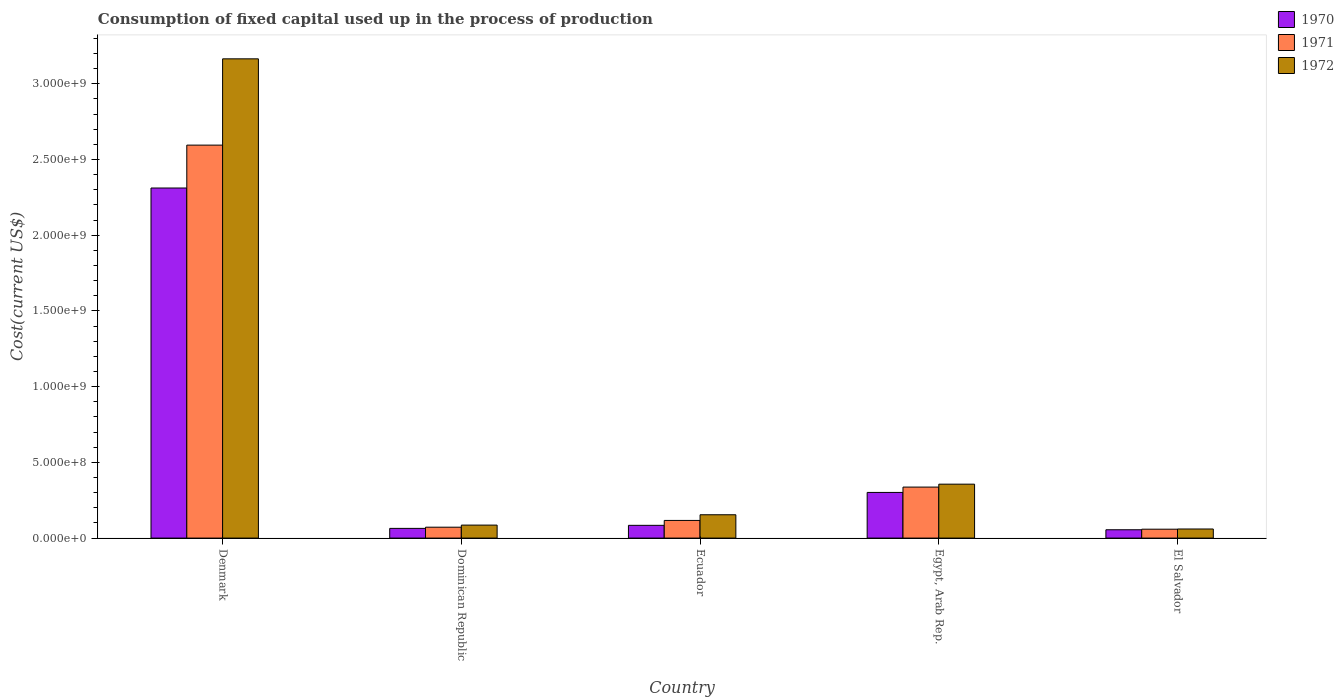How many groups of bars are there?
Offer a terse response. 5. How many bars are there on the 2nd tick from the right?
Offer a very short reply. 3. What is the label of the 3rd group of bars from the left?
Give a very brief answer. Ecuador. In how many cases, is the number of bars for a given country not equal to the number of legend labels?
Provide a succinct answer. 0. What is the amount consumed in the process of production in 1970 in El Salvador?
Offer a very short reply. 5.51e+07. Across all countries, what is the maximum amount consumed in the process of production in 1971?
Make the answer very short. 2.60e+09. Across all countries, what is the minimum amount consumed in the process of production in 1971?
Your response must be concise. 5.88e+07. In which country was the amount consumed in the process of production in 1971 maximum?
Provide a succinct answer. Denmark. In which country was the amount consumed in the process of production in 1972 minimum?
Keep it short and to the point. El Salvador. What is the total amount consumed in the process of production in 1972 in the graph?
Make the answer very short. 3.82e+09. What is the difference between the amount consumed in the process of production in 1971 in Dominican Republic and that in Ecuador?
Ensure brevity in your answer.  -4.47e+07. What is the difference between the amount consumed in the process of production in 1970 in Ecuador and the amount consumed in the process of production in 1971 in Denmark?
Keep it short and to the point. -2.51e+09. What is the average amount consumed in the process of production in 1970 per country?
Ensure brevity in your answer.  5.63e+08. What is the difference between the amount consumed in the process of production of/in 1970 and amount consumed in the process of production of/in 1972 in Dominican Republic?
Your answer should be compact. -2.17e+07. In how many countries, is the amount consumed in the process of production in 1970 greater than 2300000000 US$?
Your answer should be compact. 1. What is the ratio of the amount consumed in the process of production in 1970 in Dominican Republic to that in Egypt, Arab Rep.?
Your answer should be very brief. 0.21. Is the difference between the amount consumed in the process of production in 1970 in Ecuador and El Salvador greater than the difference between the amount consumed in the process of production in 1972 in Ecuador and El Salvador?
Provide a short and direct response. No. What is the difference between the highest and the second highest amount consumed in the process of production in 1972?
Give a very brief answer. -2.02e+08. What is the difference between the highest and the lowest amount consumed in the process of production in 1971?
Keep it short and to the point. 2.54e+09. In how many countries, is the amount consumed in the process of production in 1971 greater than the average amount consumed in the process of production in 1971 taken over all countries?
Offer a very short reply. 1. What does the 2nd bar from the left in Ecuador represents?
Provide a short and direct response. 1971. What does the 1st bar from the right in El Salvador represents?
Provide a succinct answer. 1972. Is it the case that in every country, the sum of the amount consumed in the process of production in 1972 and amount consumed in the process of production in 1971 is greater than the amount consumed in the process of production in 1970?
Ensure brevity in your answer.  Yes. How many countries are there in the graph?
Your response must be concise. 5. What is the difference between two consecutive major ticks on the Y-axis?
Provide a short and direct response. 5.00e+08. Are the values on the major ticks of Y-axis written in scientific E-notation?
Keep it short and to the point. Yes. Does the graph contain any zero values?
Your answer should be compact. No. Where does the legend appear in the graph?
Give a very brief answer. Top right. How many legend labels are there?
Your answer should be very brief. 3. What is the title of the graph?
Your answer should be compact. Consumption of fixed capital used up in the process of production. What is the label or title of the Y-axis?
Offer a very short reply. Cost(current US$). What is the Cost(current US$) in 1970 in Denmark?
Keep it short and to the point. 2.31e+09. What is the Cost(current US$) of 1971 in Denmark?
Provide a succinct answer. 2.60e+09. What is the Cost(current US$) in 1972 in Denmark?
Make the answer very short. 3.17e+09. What is the Cost(current US$) of 1970 in Dominican Republic?
Keep it short and to the point. 6.41e+07. What is the Cost(current US$) of 1971 in Dominican Republic?
Your answer should be compact. 7.20e+07. What is the Cost(current US$) in 1972 in Dominican Republic?
Provide a succinct answer. 8.58e+07. What is the Cost(current US$) in 1970 in Ecuador?
Your answer should be very brief. 8.43e+07. What is the Cost(current US$) of 1971 in Ecuador?
Your answer should be very brief. 1.17e+08. What is the Cost(current US$) of 1972 in Ecuador?
Your response must be concise. 1.54e+08. What is the Cost(current US$) in 1970 in Egypt, Arab Rep.?
Offer a very short reply. 3.02e+08. What is the Cost(current US$) in 1971 in Egypt, Arab Rep.?
Your response must be concise. 3.37e+08. What is the Cost(current US$) in 1972 in Egypt, Arab Rep.?
Give a very brief answer. 3.56e+08. What is the Cost(current US$) in 1970 in El Salvador?
Keep it short and to the point. 5.51e+07. What is the Cost(current US$) of 1971 in El Salvador?
Give a very brief answer. 5.88e+07. What is the Cost(current US$) in 1972 in El Salvador?
Provide a short and direct response. 6.01e+07. Across all countries, what is the maximum Cost(current US$) of 1970?
Offer a terse response. 2.31e+09. Across all countries, what is the maximum Cost(current US$) of 1971?
Provide a short and direct response. 2.60e+09. Across all countries, what is the maximum Cost(current US$) in 1972?
Provide a succinct answer. 3.17e+09. Across all countries, what is the minimum Cost(current US$) of 1970?
Offer a very short reply. 5.51e+07. Across all countries, what is the minimum Cost(current US$) of 1971?
Provide a short and direct response. 5.88e+07. Across all countries, what is the minimum Cost(current US$) of 1972?
Give a very brief answer. 6.01e+07. What is the total Cost(current US$) of 1970 in the graph?
Ensure brevity in your answer.  2.82e+09. What is the total Cost(current US$) of 1971 in the graph?
Your response must be concise. 3.18e+09. What is the total Cost(current US$) of 1972 in the graph?
Your answer should be very brief. 3.82e+09. What is the difference between the Cost(current US$) in 1970 in Denmark and that in Dominican Republic?
Your answer should be compact. 2.25e+09. What is the difference between the Cost(current US$) in 1971 in Denmark and that in Dominican Republic?
Offer a very short reply. 2.52e+09. What is the difference between the Cost(current US$) of 1972 in Denmark and that in Dominican Republic?
Your answer should be compact. 3.08e+09. What is the difference between the Cost(current US$) in 1970 in Denmark and that in Ecuador?
Offer a terse response. 2.23e+09. What is the difference between the Cost(current US$) in 1971 in Denmark and that in Ecuador?
Keep it short and to the point. 2.48e+09. What is the difference between the Cost(current US$) of 1972 in Denmark and that in Ecuador?
Give a very brief answer. 3.01e+09. What is the difference between the Cost(current US$) in 1970 in Denmark and that in Egypt, Arab Rep.?
Your response must be concise. 2.01e+09. What is the difference between the Cost(current US$) in 1971 in Denmark and that in Egypt, Arab Rep.?
Your answer should be very brief. 2.26e+09. What is the difference between the Cost(current US$) of 1972 in Denmark and that in Egypt, Arab Rep.?
Offer a terse response. 2.81e+09. What is the difference between the Cost(current US$) in 1970 in Denmark and that in El Salvador?
Give a very brief answer. 2.26e+09. What is the difference between the Cost(current US$) of 1971 in Denmark and that in El Salvador?
Give a very brief answer. 2.54e+09. What is the difference between the Cost(current US$) in 1972 in Denmark and that in El Salvador?
Provide a short and direct response. 3.11e+09. What is the difference between the Cost(current US$) in 1970 in Dominican Republic and that in Ecuador?
Provide a succinct answer. -2.01e+07. What is the difference between the Cost(current US$) of 1971 in Dominican Republic and that in Ecuador?
Your response must be concise. -4.47e+07. What is the difference between the Cost(current US$) of 1972 in Dominican Republic and that in Ecuador?
Make the answer very short. -6.83e+07. What is the difference between the Cost(current US$) in 1970 in Dominican Republic and that in Egypt, Arab Rep.?
Keep it short and to the point. -2.37e+08. What is the difference between the Cost(current US$) of 1971 in Dominican Republic and that in Egypt, Arab Rep.?
Keep it short and to the point. -2.65e+08. What is the difference between the Cost(current US$) in 1972 in Dominican Republic and that in Egypt, Arab Rep.?
Your answer should be compact. -2.70e+08. What is the difference between the Cost(current US$) of 1970 in Dominican Republic and that in El Salvador?
Make the answer very short. 9.05e+06. What is the difference between the Cost(current US$) in 1971 in Dominican Republic and that in El Salvador?
Make the answer very short. 1.32e+07. What is the difference between the Cost(current US$) of 1972 in Dominican Republic and that in El Salvador?
Give a very brief answer. 2.57e+07. What is the difference between the Cost(current US$) in 1970 in Ecuador and that in Egypt, Arab Rep.?
Your response must be concise. -2.17e+08. What is the difference between the Cost(current US$) of 1971 in Ecuador and that in Egypt, Arab Rep.?
Your response must be concise. -2.20e+08. What is the difference between the Cost(current US$) in 1972 in Ecuador and that in Egypt, Arab Rep.?
Keep it short and to the point. -2.02e+08. What is the difference between the Cost(current US$) in 1970 in Ecuador and that in El Salvador?
Offer a very short reply. 2.92e+07. What is the difference between the Cost(current US$) in 1971 in Ecuador and that in El Salvador?
Offer a very short reply. 5.79e+07. What is the difference between the Cost(current US$) in 1972 in Ecuador and that in El Salvador?
Your response must be concise. 9.40e+07. What is the difference between the Cost(current US$) in 1970 in Egypt, Arab Rep. and that in El Salvador?
Your answer should be compact. 2.47e+08. What is the difference between the Cost(current US$) in 1971 in Egypt, Arab Rep. and that in El Salvador?
Your answer should be very brief. 2.78e+08. What is the difference between the Cost(current US$) of 1972 in Egypt, Arab Rep. and that in El Salvador?
Your answer should be compact. 2.96e+08. What is the difference between the Cost(current US$) in 1970 in Denmark and the Cost(current US$) in 1971 in Dominican Republic?
Offer a terse response. 2.24e+09. What is the difference between the Cost(current US$) in 1970 in Denmark and the Cost(current US$) in 1972 in Dominican Republic?
Provide a short and direct response. 2.23e+09. What is the difference between the Cost(current US$) of 1971 in Denmark and the Cost(current US$) of 1972 in Dominican Republic?
Provide a short and direct response. 2.51e+09. What is the difference between the Cost(current US$) in 1970 in Denmark and the Cost(current US$) in 1971 in Ecuador?
Make the answer very short. 2.20e+09. What is the difference between the Cost(current US$) of 1970 in Denmark and the Cost(current US$) of 1972 in Ecuador?
Ensure brevity in your answer.  2.16e+09. What is the difference between the Cost(current US$) in 1971 in Denmark and the Cost(current US$) in 1972 in Ecuador?
Offer a very short reply. 2.44e+09. What is the difference between the Cost(current US$) in 1970 in Denmark and the Cost(current US$) in 1971 in Egypt, Arab Rep.?
Keep it short and to the point. 1.98e+09. What is the difference between the Cost(current US$) in 1970 in Denmark and the Cost(current US$) in 1972 in Egypt, Arab Rep.?
Keep it short and to the point. 1.96e+09. What is the difference between the Cost(current US$) of 1971 in Denmark and the Cost(current US$) of 1972 in Egypt, Arab Rep.?
Give a very brief answer. 2.24e+09. What is the difference between the Cost(current US$) of 1970 in Denmark and the Cost(current US$) of 1971 in El Salvador?
Offer a terse response. 2.25e+09. What is the difference between the Cost(current US$) in 1970 in Denmark and the Cost(current US$) in 1972 in El Salvador?
Offer a very short reply. 2.25e+09. What is the difference between the Cost(current US$) of 1971 in Denmark and the Cost(current US$) of 1972 in El Salvador?
Provide a succinct answer. 2.54e+09. What is the difference between the Cost(current US$) of 1970 in Dominican Republic and the Cost(current US$) of 1971 in Ecuador?
Give a very brief answer. -5.25e+07. What is the difference between the Cost(current US$) of 1970 in Dominican Republic and the Cost(current US$) of 1972 in Ecuador?
Offer a very short reply. -9.00e+07. What is the difference between the Cost(current US$) of 1971 in Dominican Republic and the Cost(current US$) of 1972 in Ecuador?
Offer a terse response. -8.21e+07. What is the difference between the Cost(current US$) of 1970 in Dominican Republic and the Cost(current US$) of 1971 in Egypt, Arab Rep.?
Your answer should be very brief. -2.73e+08. What is the difference between the Cost(current US$) in 1970 in Dominican Republic and the Cost(current US$) in 1972 in Egypt, Arab Rep.?
Offer a very short reply. -2.92e+08. What is the difference between the Cost(current US$) in 1971 in Dominican Republic and the Cost(current US$) in 1972 in Egypt, Arab Rep.?
Your response must be concise. -2.84e+08. What is the difference between the Cost(current US$) in 1970 in Dominican Republic and the Cost(current US$) in 1971 in El Salvador?
Provide a short and direct response. 5.36e+06. What is the difference between the Cost(current US$) in 1970 in Dominican Republic and the Cost(current US$) in 1972 in El Salvador?
Your answer should be compact. 4.06e+06. What is the difference between the Cost(current US$) of 1971 in Dominican Republic and the Cost(current US$) of 1972 in El Salvador?
Offer a very short reply. 1.19e+07. What is the difference between the Cost(current US$) in 1970 in Ecuador and the Cost(current US$) in 1971 in Egypt, Arab Rep.?
Offer a very short reply. -2.53e+08. What is the difference between the Cost(current US$) in 1970 in Ecuador and the Cost(current US$) in 1972 in Egypt, Arab Rep.?
Keep it short and to the point. -2.72e+08. What is the difference between the Cost(current US$) of 1971 in Ecuador and the Cost(current US$) of 1972 in Egypt, Arab Rep.?
Provide a short and direct response. -2.39e+08. What is the difference between the Cost(current US$) of 1970 in Ecuador and the Cost(current US$) of 1971 in El Salvador?
Offer a very short reply. 2.55e+07. What is the difference between the Cost(current US$) in 1970 in Ecuador and the Cost(current US$) in 1972 in El Salvador?
Offer a terse response. 2.42e+07. What is the difference between the Cost(current US$) of 1971 in Ecuador and the Cost(current US$) of 1972 in El Salvador?
Offer a terse response. 5.66e+07. What is the difference between the Cost(current US$) in 1970 in Egypt, Arab Rep. and the Cost(current US$) in 1971 in El Salvador?
Your answer should be compact. 2.43e+08. What is the difference between the Cost(current US$) in 1970 in Egypt, Arab Rep. and the Cost(current US$) in 1972 in El Salvador?
Your response must be concise. 2.42e+08. What is the difference between the Cost(current US$) of 1971 in Egypt, Arab Rep. and the Cost(current US$) of 1972 in El Salvador?
Give a very brief answer. 2.77e+08. What is the average Cost(current US$) in 1970 per country?
Your answer should be compact. 5.63e+08. What is the average Cost(current US$) in 1971 per country?
Offer a very short reply. 6.36e+08. What is the average Cost(current US$) of 1972 per country?
Your answer should be compact. 7.64e+08. What is the difference between the Cost(current US$) in 1970 and Cost(current US$) in 1971 in Denmark?
Your answer should be very brief. -2.83e+08. What is the difference between the Cost(current US$) in 1970 and Cost(current US$) in 1972 in Denmark?
Provide a succinct answer. -8.53e+08. What is the difference between the Cost(current US$) of 1971 and Cost(current US$) of 1972 in Denmark?
Give a very brief answer. -5.70e+08. What is the difference between the Cost(current US$) of 1970 and Cost(current US$) of 1971 in Dominican Republic?
Provide a succinct answer. -7.86e+06. What is the difference between the Cost(current US$) of 1970 and Cost(current US$) of 1972 in Dominican Republic?
Your response must be concise. -2.17e+07. What is the difference between the Cost(current US$) in 1971 and Cost(current US$) in 1972 in Dominican Republic?
Ensure brevity in your answer.  -1.38e+07. What is the difference between the Cost(current US$) of 1970 and Cost(current US$) of 1971 in Ecuador?
Offer a very short reply. -3.24e+07. What is the difference between the Cost(current US$) of 1970 and Cost(current US$) of 1972 in Ecuador?
Offer a terse response. -6.99e+07. What is the difference between the Cost(current US$) in 1971 and Cost(current US$) in 1972 in Ecuador?
Offer a terse response. -3.74e+07. What is the difference between the Cost(current US$) of 1970 and Cost(current US$) of 1971 in Egypt, Arab Rep.?
Your answer should be very brief. -3.52e+07. What is the difference between the Cost(current US$) of 1970 and Cost(current US$) of 1972 in Egypt, Arab Rep.?
Provide a succinct answer. -5.45e+07. What is the difference between the Cost(current US$) of 1971 and Cost(current US$) of 1972 in Egypt, Arab Rep.?
Offer a terse response. -1.93e+07. What is the difference between the Cost(current US$) of 1970 and Cost(current US$) of 1971 in El Salvador?
Keep it short and to the point. -3.70e+06. What is the difference between the Cost(current US$) of 1970 and Cost(current US$) of 1972 in El Salvador?
Your response must be concise. -4.99e+06. What is the difference between the Cost(current US$) in 1971 and Cost(current US$) in 1972 in El Salvador?
Provide a short and direct response. -1.29e+06. What is the ratio of the Cost(current US$) in 1970 in Denmark to that in Dominican Republic?
Offer a terse response. 36.05. What is the ratio of the Cost(current US$) in 1971 in Denmark to that in Dominican Republic?
Give a very brief answer. 36.05. What is the ratio of the Cost(current US$) in 1972 in Denmark to that in Dominican Republic?
Your answer should be compact. 36.89. What is the ratio of the Cost(current US$) of 1970 in Denmark to that in Ecuador?
Provide a succinct answer. 27.44. What is the ratio of the Cost(current US$) of 1971 in Denmark to that in Ecuador?
Offer a very short reply. 22.25. What is the ratio of the Cost(current US$) of 1972 in Denmark to that in Ecuador?
Your response must be concise. 20.54. What is the ratio of the Cost(current US$) in 1970 in Denmark to that in Egypt, Arab Rep.?
Ensure brevity in your answer.  7.67. What is the ratio of the Cost(current US$) of 1971 in Denmark to that in Egypt, Arab Rep.?
Ensure brevity in your answer.  7.71. What is the ratio of the Cost(current US$) in 1972 in Denmark to that in Egypt, Arab Rep.?
Offer a very short reply. 8.89. What is the ratio of the Cost(current US$) in 1970 in Denmark to that in El Salvador?
Give a very brief answer. 41.98. What is the ratio of the Cost(current US$) in 1971 in Denmark to that in El Salvador?
Provide a succinct answer. 44.15. What is the ratio of the Cost(current US$) in 1972 in Denmark to that in El Salvador?
Make the answer very short. 52.69. What is the ratio of the Cost(current US$) of 1970 in Dominican Republic to that in Ecuador?
Provide a short and direct response. 0.76. What is the ratio of the Cost(current US$) in 1971 in Dominican Republic to that in Ecuador?
Offer a terse response. 0.62. What is the ratio of the Cost(current US$) in 1972 in Dominican Republic to that in Ecuador?
Give a very brief answer. 0.56. What is the ratio of the Cost(current US$) in 1970 in Dominican Republic to that in Egypt, Arab Rep.?
Your answer should be compact. 0.21. What is the ratio of the Cost(current US$) of 1971 in Dominican Republic to that in Egypt, Arab Rep.?
Ensure brevity in your answer.  0.21. What is the ratio of the Cost(current US$) in 1972 in Dominican Republic to that in Egypt, Arab Rep.?
Make the answer very short. 0.24. What is the ratio of the Cost(current US$) in 1970 in Dominican Republic to that in El Salvador?
Provide a short and direct response. 1.16. What is the ratio of the Cost(current US$) of 1971 in Dominican Republic to that in El Salvador?
Keep it short and to the point. 1.22. What is the ratio of the Cost(current US$) in 1972 in Dominican Republic to that in El Salvador?
Give a very brief answer. 1.43. What is the ratio of the Cost(current US$) in 1970 in Ecuador to that in Egypt, Arab Rep.?
Your answer should be compact. 0.28. What is the ratio of the Cost(current US$) of 1971 in Ecuador to that in Egypt, Arab Rep.?
Provide a succinct answer. 0.35. What is the ratio of the Cost(current US$) in 1972 in Ecuador to that in Egypt, Arab Rep.?
Your response must be concise. 0.43. What is the ratio of the Cost(current US$) of 1970 in Ecuador to that in El Salvador?
Offer a very short reply. 1.53. What is the ratio of the Cost(current US$) of 1971 in Ecuador to that in El Salvador?
Offer a very short reply. 1.98. What is the ratio of the Cost(current US$) in 1972 in Ecuador to that in El Salvador?
Your answer should be compact. 2.57. What is the ratio of the Cost(current US$) of 1970 in Egypt, Arab Rep. to that in El Salvador?
Give a very brief answer. 5.48. What is the ratio of the Cost(current US$) in 1971 in Egypt, Arab Rep. to that in El Salvador?
Keep it short and to the point. 5.73. What is the ratio of the Cost(current US$) of 1972 in Egypt, Arab Rep. to that in El Salvador?
Your response must be concise. 5.93. What is the difference between the highest and the second highest Cost(current US$) of 1970?
Ensure brevity in your answer.  2.01e+09. What is the difference between the highest and the second highest Cost(current US$) of 1971?
Your response must be concise. 2.26e+09. What is the difference between the highest and the second highest Cost(current US$) of 1972?
Provide a succinct answer. 2.81e+09. What is the difference between the highest and the lowest Cost(current US$) of 1970?
Provide a short and direct response. 2.26e+09. What is the difference between the highest and the lowest Cost(current US$) in 1971?
Make the answer very short. 2.54e+09. What is the difference between the highest and the lowest Cost(current US$) in 1972?
Offer a very short reply. 3.11e+09. 